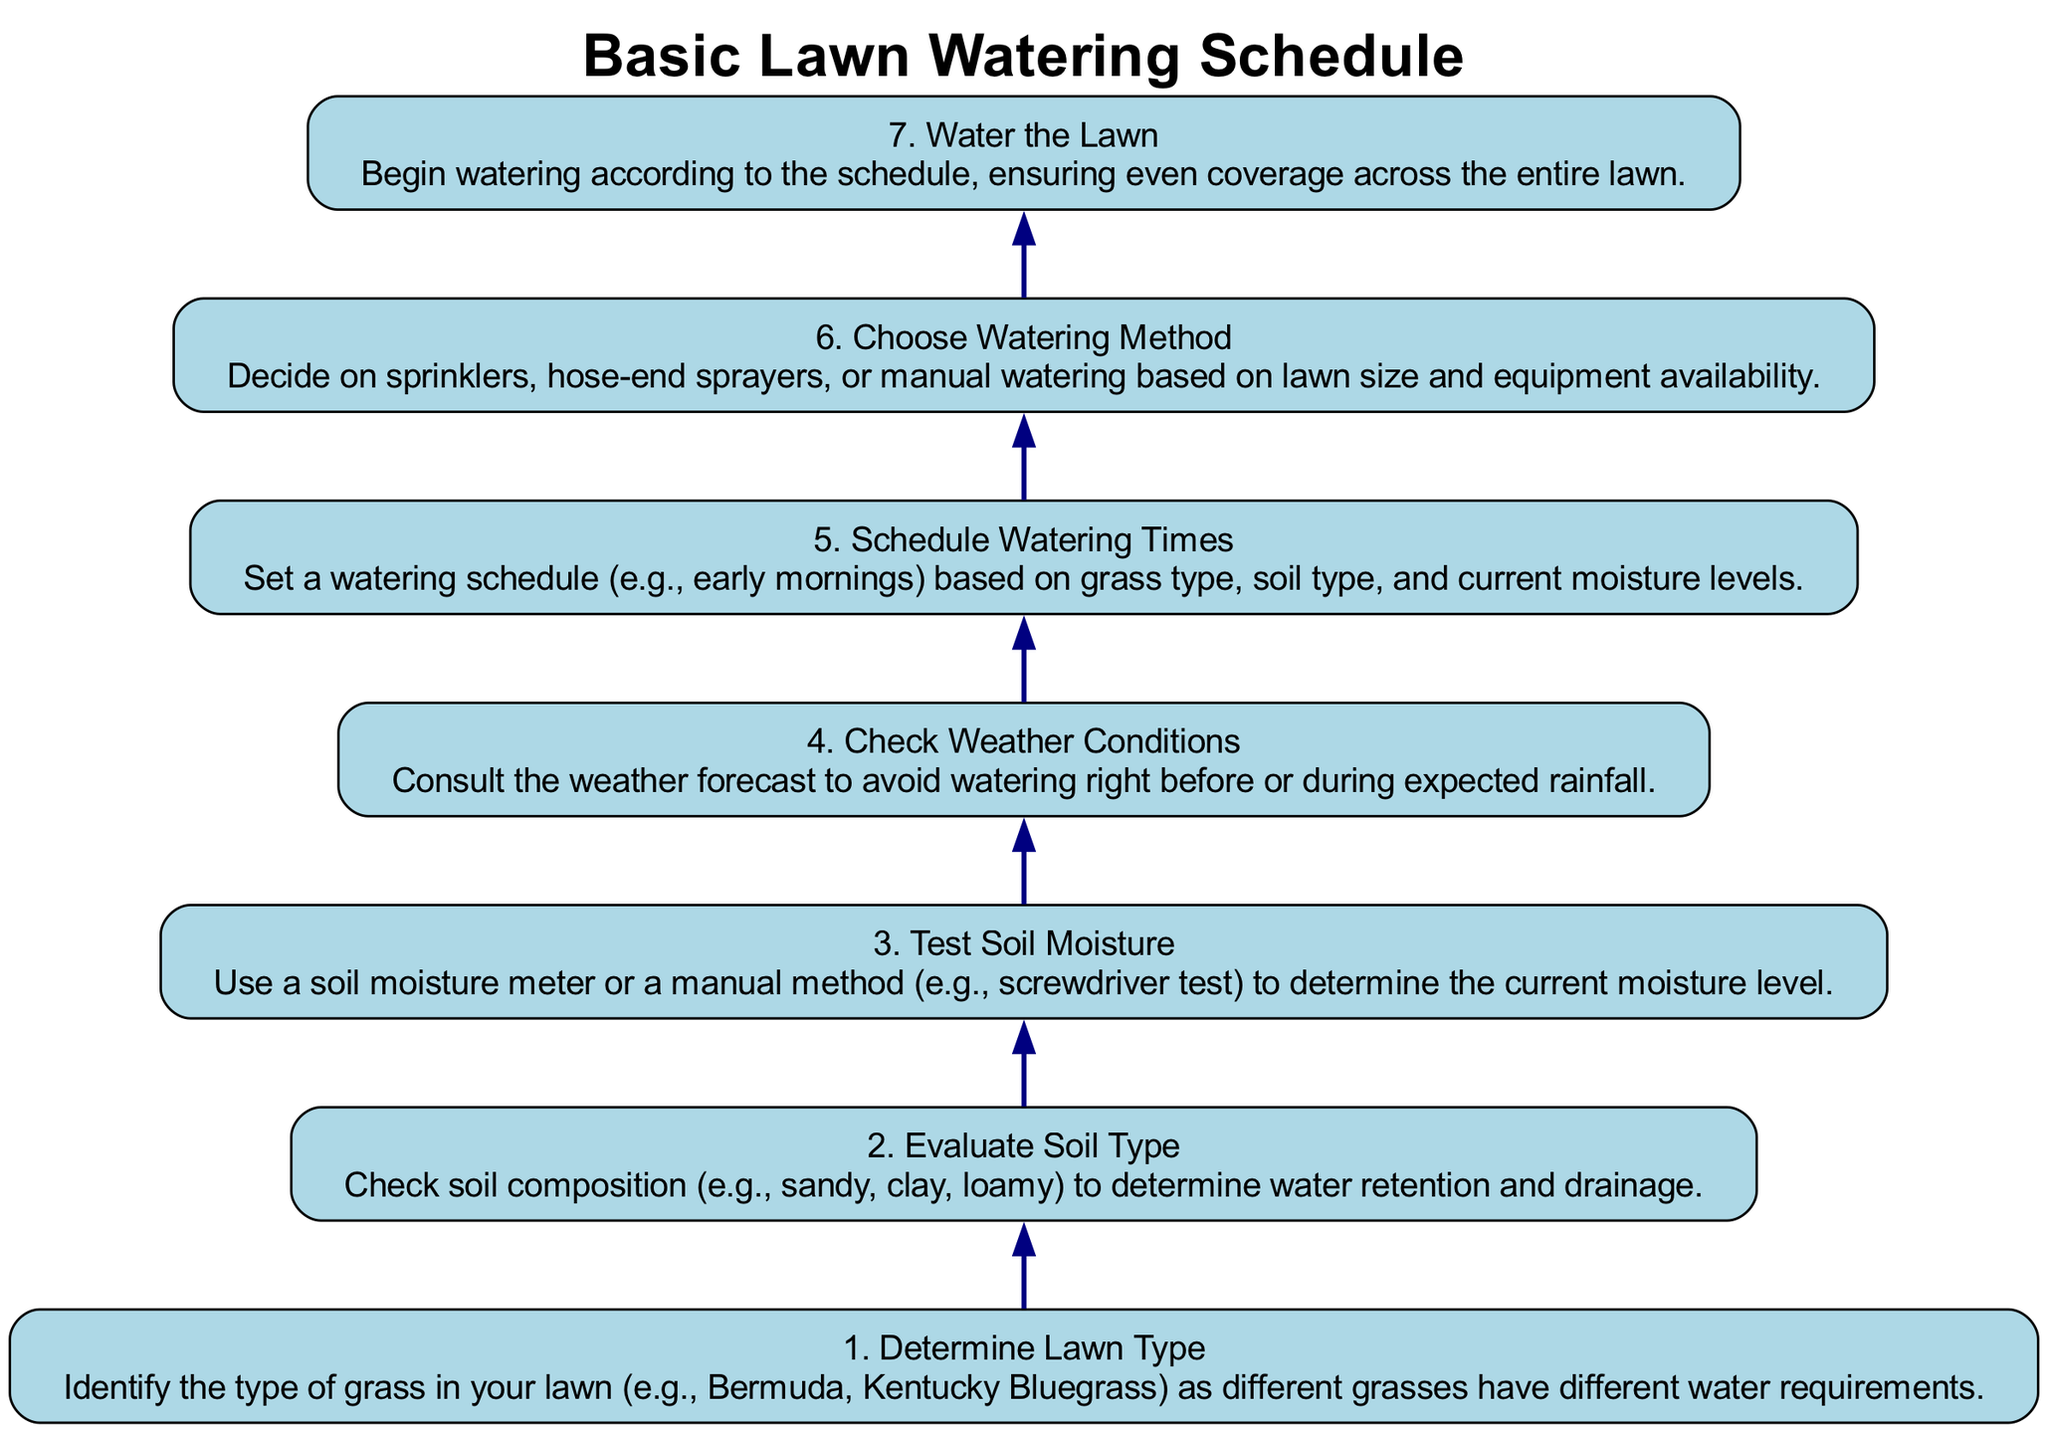What is the first step in the lawn watering schedule? The diagram indicates that the first step is to "Determine Lawn Type." This is the starting point for the entire process and is positioned at the bottom of the flow chart.
Answer: Determine Lawn Type How many total steps are there in the diagram? By counting each labeled step in the chart, we can see there are seven distinct steps.
Answer: Seven What condition should be checked after evaluating soil type? After evaluating soil type, the next step is to "Test Soil Moisture." This flows directly from the evaluation process as an important next action to determine the watering needs.
Answer: Test Soil Moisture What should you use to determine soil moisture? The diagram specifies using a "soil moisture meter or a manual method (e.g., screwdriver test)" to assess the current moisture level. This is a crucial step before scheduling any watering.
Answer: soil moisture meter or screwdriver test If current moisture is adequate, what is the next action? If the soil moisture measurement indicates it's sufficient, you would skip directly to checking the weather conditions instead of watering. This highlights the importance of moisture levels in deciding the watering schedule.
Answer: Check Weather Conditions What follows after scheduling watering times? After scheduling watering times, the following step is to "Choose Watering Method." This indicates that once you're clear on when to water, you need to decide on how to execute that task based on your resources.
Answer: Choose Watering Method Why is it important to check weather conditions? Checking weather conditions is crucial to avoid watering immediately before or during expected rainfall. This ensures efficient water use and helps prevent unnecessary watering.
Answer: To avoid watering during expected rainfall Which step comes just before watering the lawn? The step immediately preceding "Water the Lawn" is "Choose Watering Method." This emphasizes that a selection of the watering method is essential before initiating the actual watering process.
Answer: Choose Watering Method 